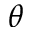<formula> <loc_0><loc_0><loc_500><loc_500>\theta</formula> 